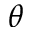<formula> <loc_0><loc_0><loc_500><loc_500>\theta</formula> 